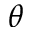<formula> <loc_0><loc_0><loc_500><loc_500>\theta</formula> 